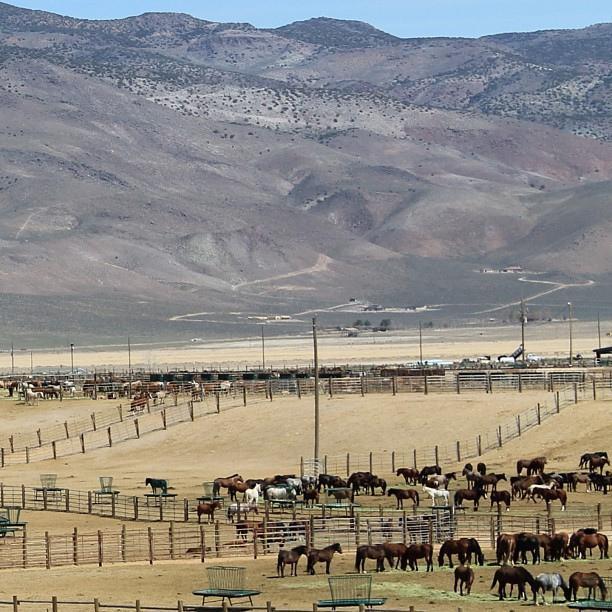How many people are wearing purple shirt?
Give a very brief answer. 0. 